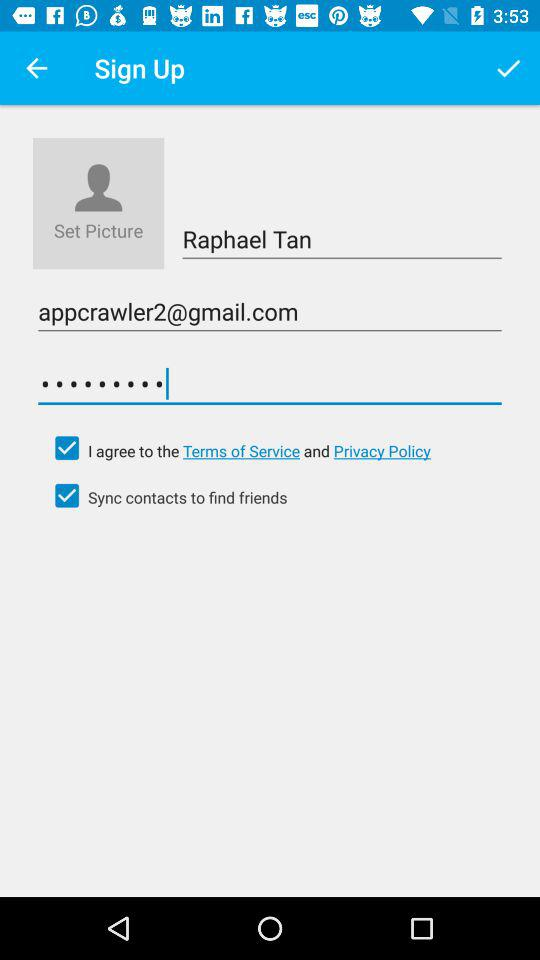What is the name of the user? The name of the user is Raphael Tan. 